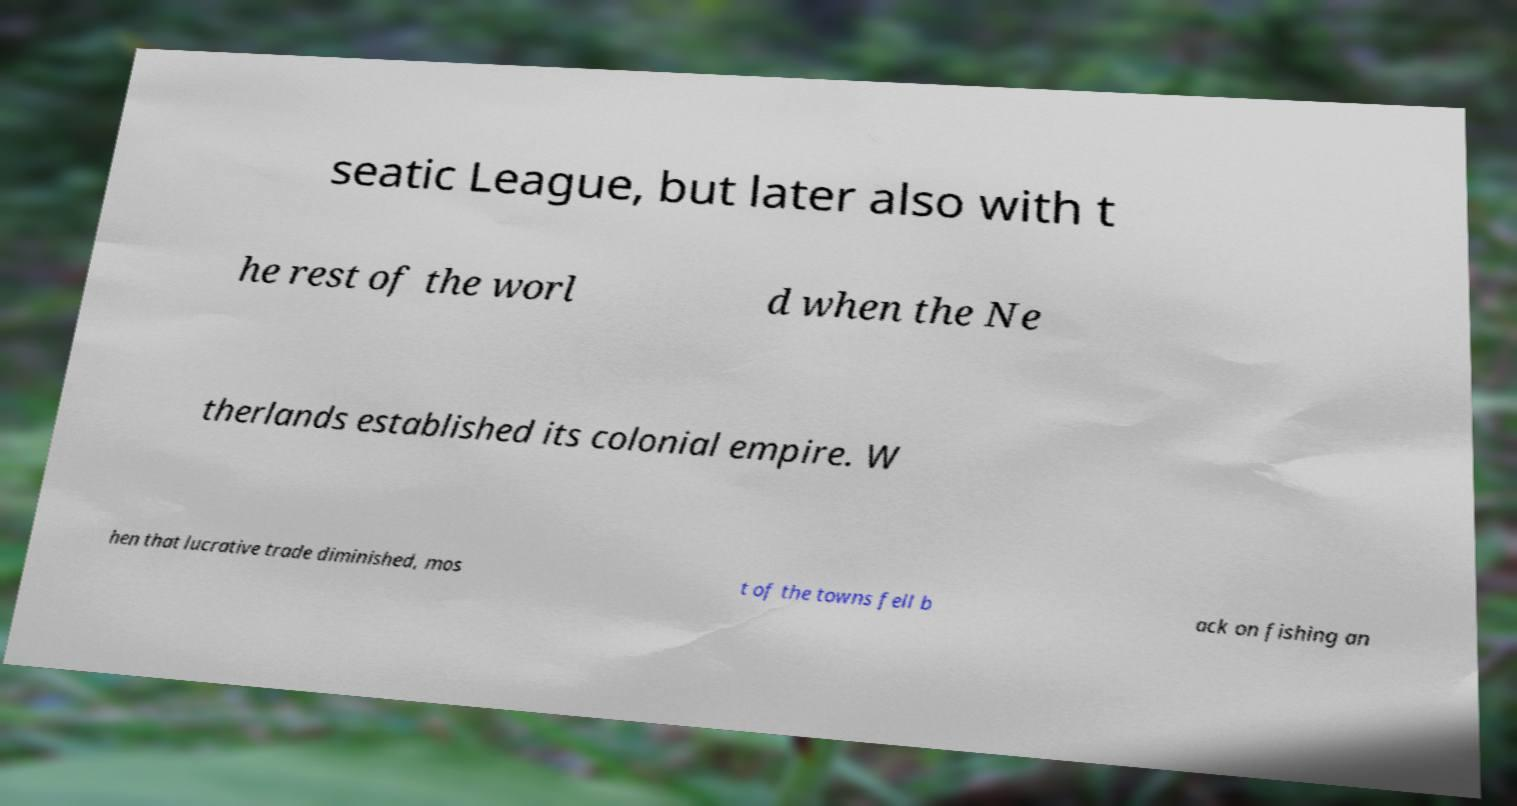Please read and relay the text visible in this image. What does it say? seatic League, but later also with t he rest of the worl d when the Ne therlands established its colonial empire. W hen that lucrative trade diminished, mos t of the towns fell b ack on fishing an 